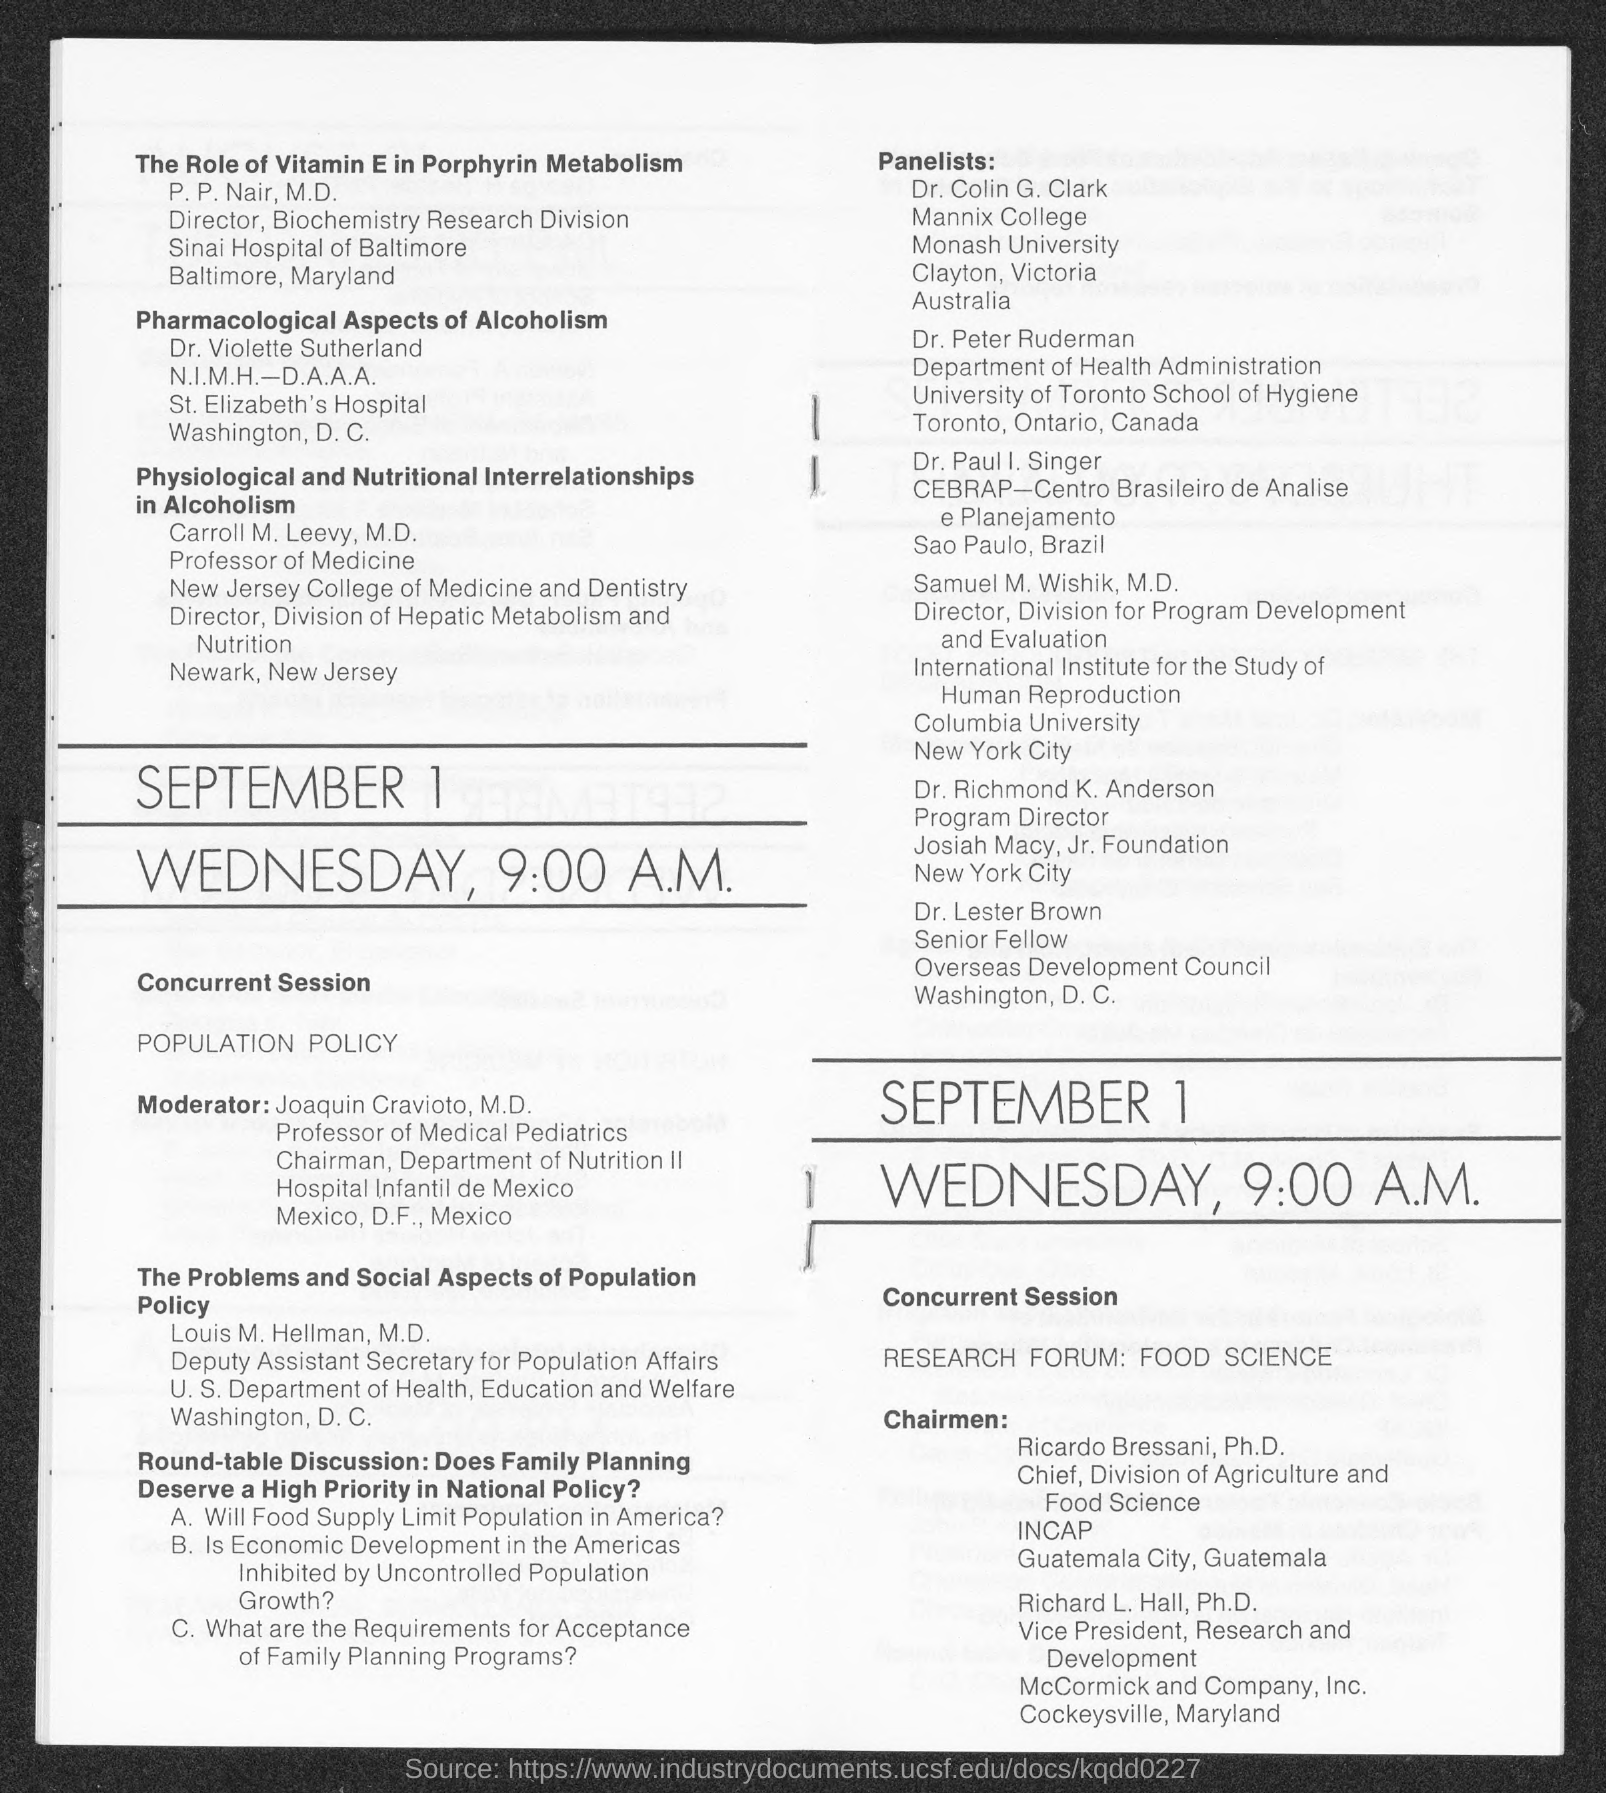Draw attention to some important aspects in this diagram. Carroll M. Leevy holds the designation of Professor of Medicine. Dr. Colin G. Clark is a member of Monash University. P.P. Nair is the Director of the Biochemistry Research Division. 